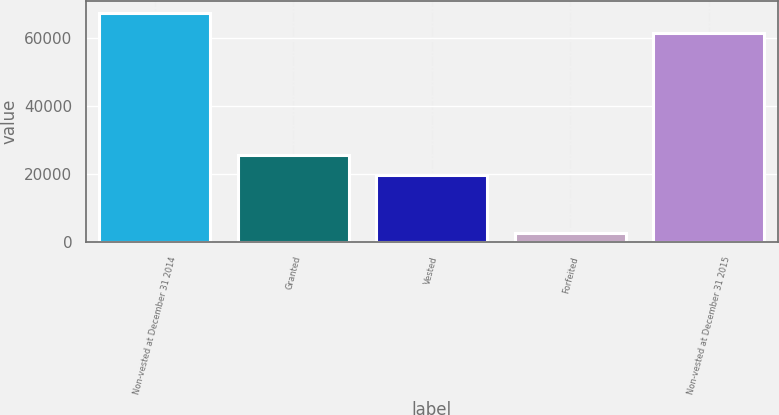Convert chart to OTSL. <chart><loc_0><loc_0><loc_500><loc_500><bar_chart><fcel>Non-vested at December 31 2014<fcel>Granted<fcel>Vested<fcel>Forfeited<fcel>Non-vested at December 31 2015<nl><fcel>67590.3<fcel>25733.3<fcel>19773<fcel>2570<fcel>61630<nl></chart> 